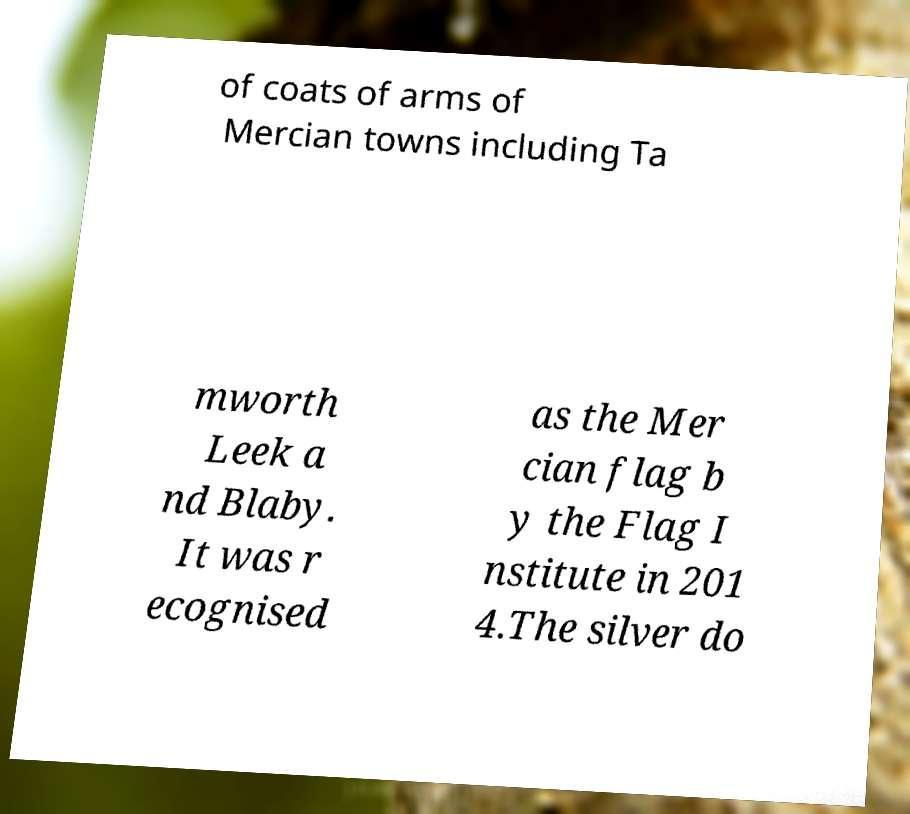Can you accurately transcribe the text from the provided image for me? of coats of arms of Mercian towns including Ta mworth Leek a nd Blaby. It was r ecognised as the Mer cian flag b y the Flag I nstitute in 201 4.The silver do 